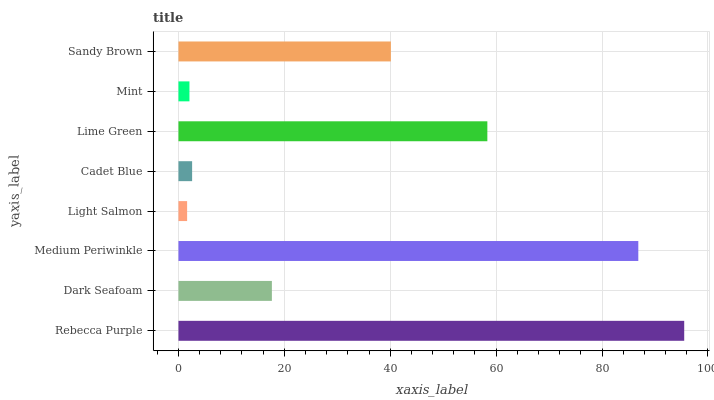Is Light Salmon the minimum?
Answer yes or no. Yes. Is Rebecca Purple the maximum?
Answer yes or no. Yes. Is Dark Seafoam the minimum?
Answer yes or no. No. Is Dark Seafoam the maximum?
Answer yes or no. No. Is Rebecca Purple greater than Dark Seafoam?
Answer yes or no. Yes. Is Dark Seafoam less than Rebecca Purple?
Answer yes or no. Yes. Is Dark Seafoam greater than Rebecca Purple?
Answer yes or no. No. Is Rebecca Purple less than Dark Seafoam?
Answer yes or no. No. Is Sandy Brown the high median?
Answer yes or no. Yes. Is Dark Seafoam the low median?
Answer yes or no. Yes. Is Mint the high median?
Answer yes or no. No. Is Mint the low median?
Answer yes or no. No. 